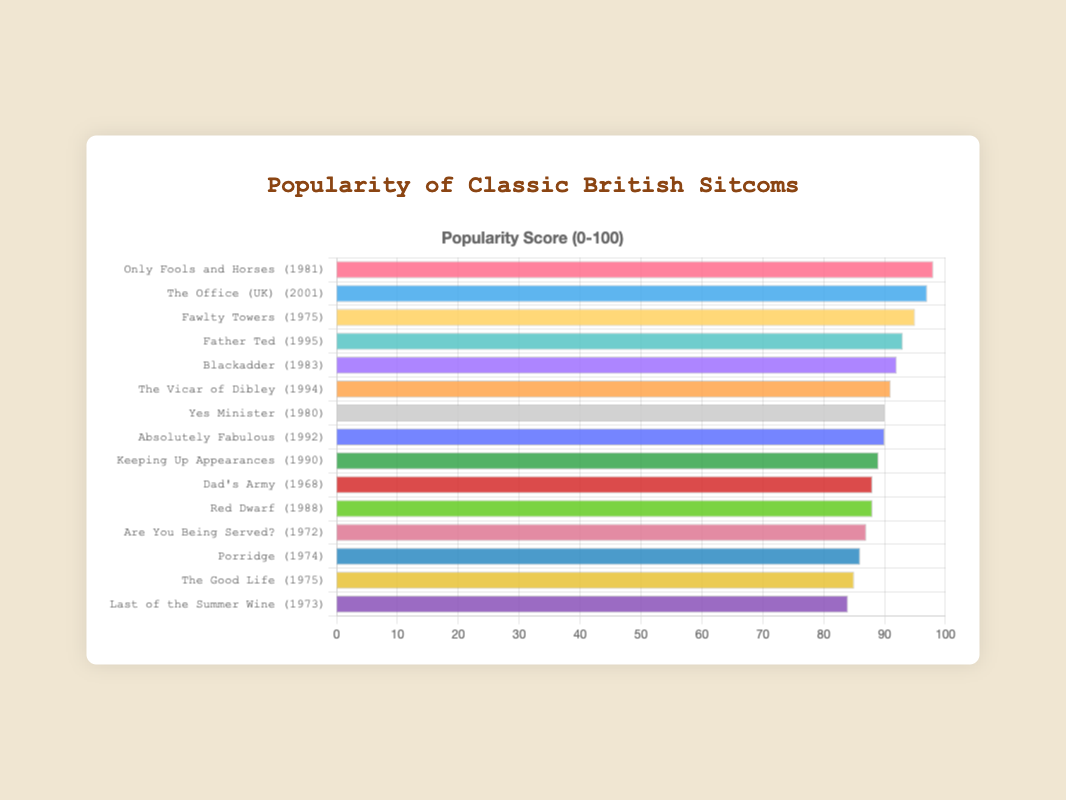Which sitcom has the highest popularity score? Look for the sitcom with the longest bar in the chart. "Only Fools and Horses" has the longest bar.
Answer: Only Fools and Horses What is the popularity score of "The Office (UK)"? Find the bar labeled "The Office (UK) (2001)" and check its length on the x-axis. It reaches a popularity score of 97.
Answer: 97 Which sitcoms released in the 1970s have a popularity score higher than 85? Identify sitcoms from the 1970s and check if their bars are longer than 85 on the x-axis. "Fawlty Towers," "The Good Life," "Porridge," and "Are You Being Served?" all meet this criterion.
Answer: Fawlty Towers, The Good Life, Porridge, Are You Being Served? What is the combined popularity score of "Fawlty Towers" and "Father Ted"? Find the bars for "Fawlty Towers (1975)" and "Father Ted (1995)" and add their lengths. 95 + 93 = 188.
Answer: 188 Which sitcom from the 1980s has the lowest popularity score? Look for the sitcoms released in the 1980s and compare their bar lengths. "Red Dwarf (1988)" has the shortest bar at a popularity score of 88.
Answer: Red Dwarf How many sitcoms have a popularity score greater than 90? Count the bars that extend beyond the 90 mark on the x-axis. There are 8 such sitcoms.
Answer: 8 What is the popularity score difference between "Yes Minister" and "Dad's Army"? Find the bars for "Yes Minister (1980)" and "Dad's Army (1968)" and subtract the length of Dad's Army from Yes Minister. 90 - 88 = 2.
Answer: 2 Which sitcom's bar is colored in red? Locate the bar with the red fill. The bar corresponding to "Only Fools and Horses (1981)" is red.
Answer: Only Fools and Horses What is the median popularity score of the sitcoms listed? Arrange the popularity scores in numerical order (84, 85, 86, 87, 88, 88, 89, 90, 90, 91, 92, 93, 95, 97, 98) and locate the middle value, which is 90.
Answer: 90 Identify the color of the bar for "Absolutely Fabulous"? Find the bar for "Absolutely Fabulous (1992)" and observe its color. It is filled with blue.
Answer: blue 